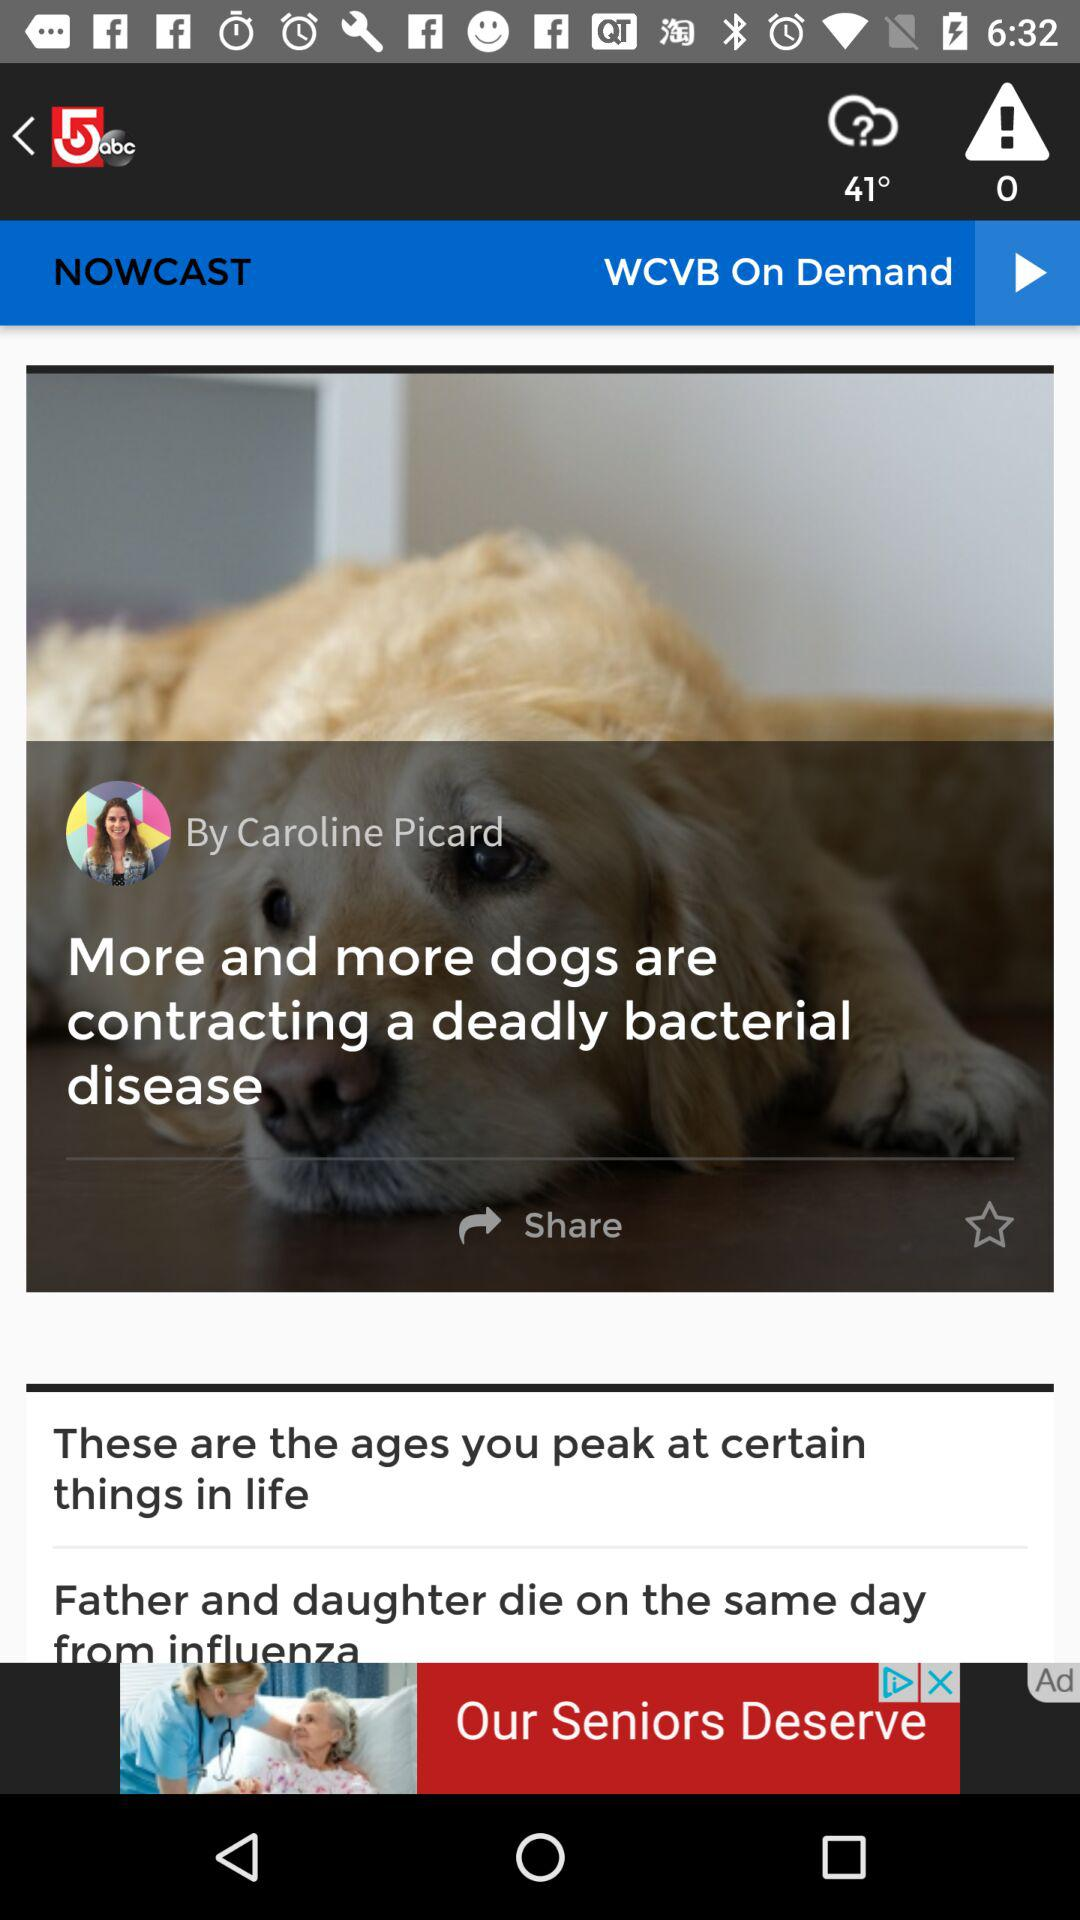What is the location?
When the provided information is insufficient, respond with <no answer>. <no answer> 